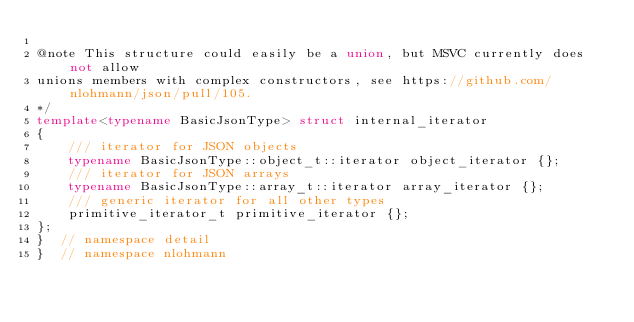<code> <loc_0><loc_0><loc_500><loc_500><_C++_>
@note This structure could easily be a union, but MSVC currently does not allow
unions members with complex constructors, see https://github.com/nlohmann/json/pull/105.
*/
template<typename BasicJsonType> struct internal_iterator
{
    /// iterator for JSON objects
    typename BasicJsonType::object_t::iterator object_iterator {};
    /// iterator for JSON arrays
    typename BasicJsonType::array_t::iterator array_iterator {};
    /// generic iterator for all other types
    primitive_iterator_t primitive_iterator {};
};
}  // namespace detail
}  // namespace nlohmann
</code> 